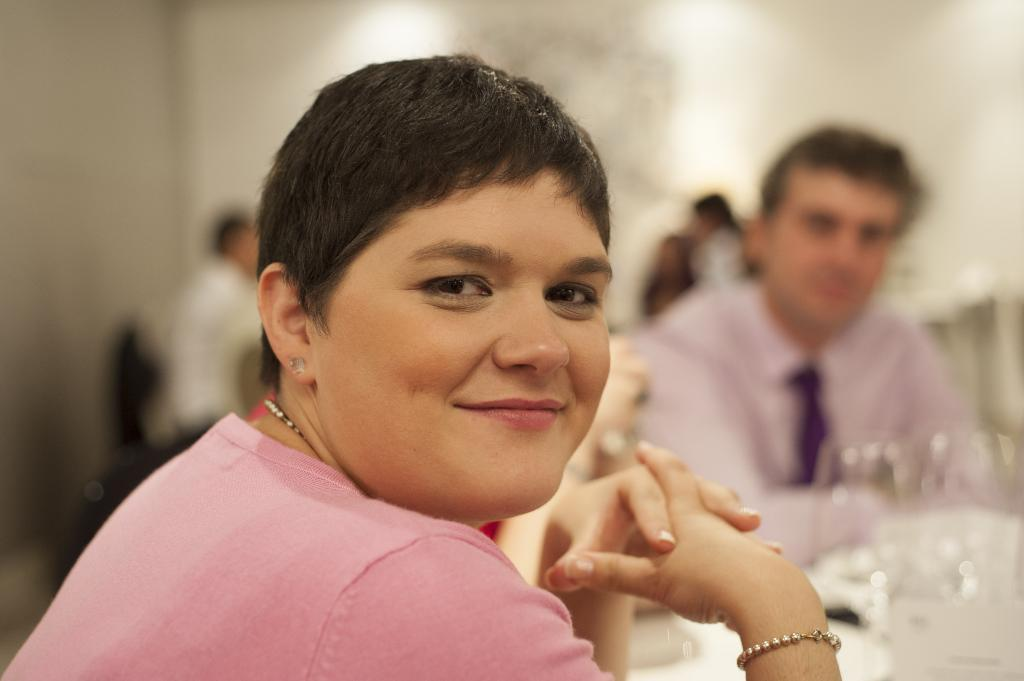What are the people in the image doing? The people in the image are sitting on chairs. What is the main piece of furniture in the image? There is a table in the image. What can be seen on the table? There are objects placed on the table. What type of sand can be seen on the calendar in the image? There is no sand or calendar present in the image. What song is being sung by the people sitting on chairs in the image? There is no indication of any song being sung in the image. 